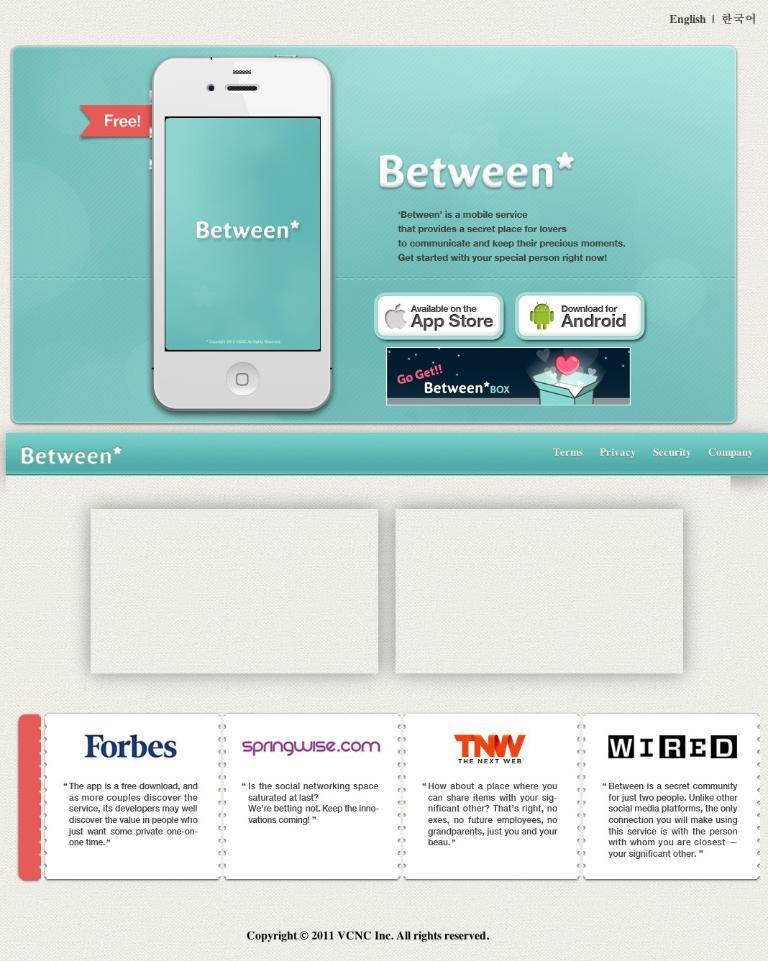Provide a one-sentence caption for the provided image. An Ad detailing the app Between with many sites giving good words at the bottom. 